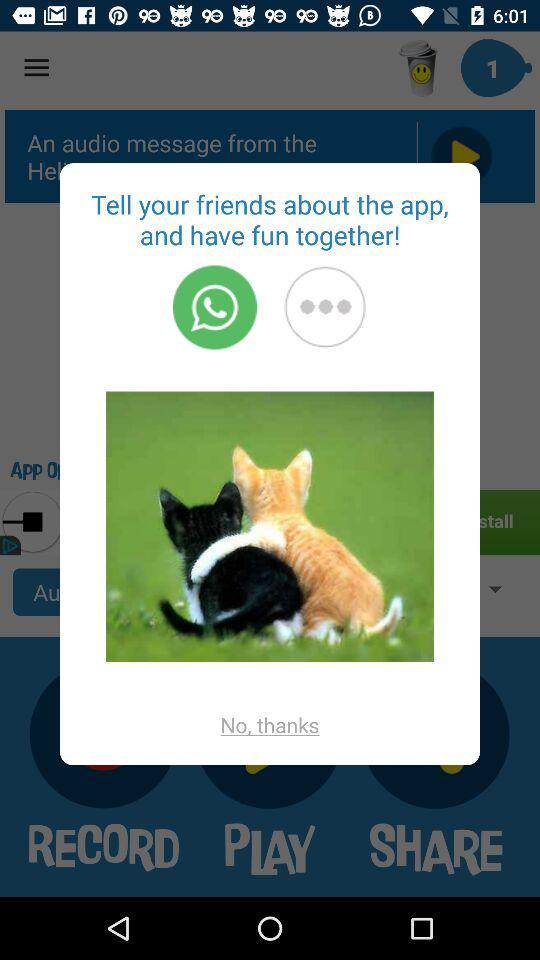What application can I use to tell my friends about the app? You can use "WhatsApp" to tell your friends about the app. 